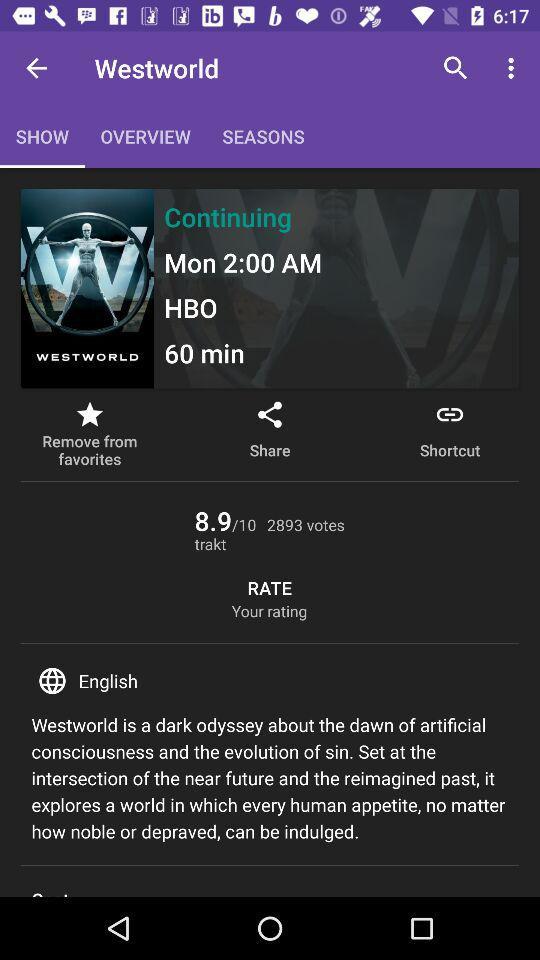How many votes are there for the show? There are 2893 votes for the show. 